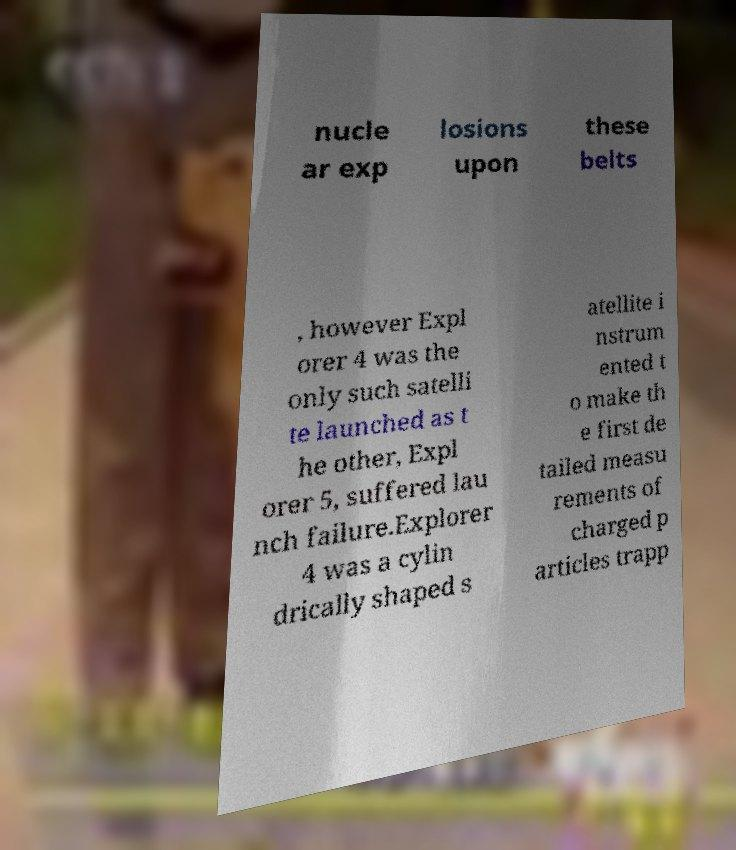Please read and relay the text visible in this image. What does it say? nucle ar exp losions upon these belts , however Expl orer 4 was the only such satelli te launched as t he other, Expl orer 5, suffered lau nch failure.Explorer 4 was a cylin drically shaped s atellite i nstrum ented t o make th e first de tailed measu rements of charged p articles trapp 